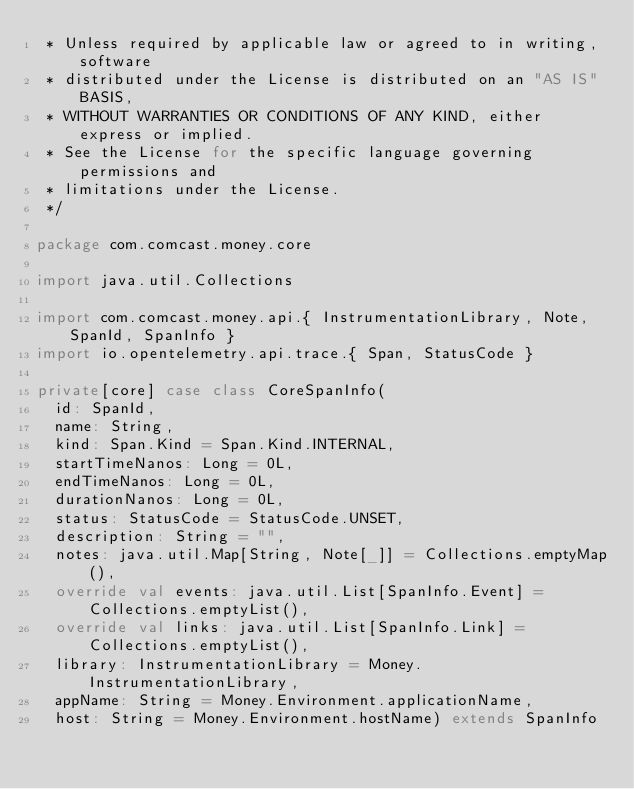Convert code to text. <code><loc_0><loc_0><loc_500><loc_500><_Scala_> * Unless required by applicable law or agreed to in writing, software
 * distributed under the License is distributed on an "AS IS" BASIS,
 * WITHOUT WARRANTIES OR CONDITIONS OF ANY KIND, either express or implied.
 * See the License for the specific language governing permissions and
 * limitations under the License.
 */

package com.comcast.money.core

import java.util.Collections

import com.comcast.money.api.{ InstrumentationLibrary, Note, SpanId, SpanInfo }
import io.opentelemetry.api.trace.{ Span, StatusCode }

private[core] case class CoreSpanInfo(
  id: SpanId,
  name: String,
  kind: Span.Kind = Span.Kind.INTERNAL,
  startTimeNanos: Long = 0L,
  endTimeNanos: Long = 0L,
  durationNanos: Long = 0L,
  status: StatusCode = StatusCode.UNSET,
  description: String = "",
  notes: java.util.Map[String, Note[_]] = Collections.emptyMap(),
  override val events: java.util.List[SpanInfo.Event] = Collections.emptyList(),
  override val links: java.util.List[SpanInfo.Link] = Collections.emptyList(),
  library: InstrumentationLibrary = Money.InstrumentationLibrary,
  appName: String = Money.Environment.applicationName,
  host: String = Money.Environment.hostName) extends SpanInfo</code> 